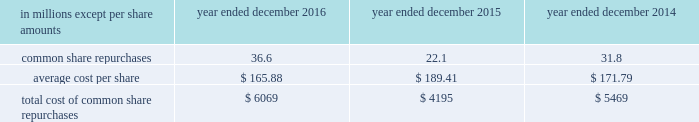The goldman sachs group , inc .
And subsidiaries notes to consolidated financial statements in connection with the firm 2019s prime brokerage and clearing businesses , the firm agrees to clear and settle on behalf of its clients the transactions entered into by them with other brokerage firms .
The firm 2019s obligations in respect of such transactions are secured by the assets in the client 2019s account as well as any proceeds received from the transactions cleared and settled by the firm on behalf of the client .
In connection with joint venture investments , the firm may issue loan guarantees under which it may be liable in the event of fraud , misappropriation , environmental liabilities and certain other matters involving the borrower .
The firm is unable to develop an estimate of the maximum payout under these guarantees and indemnifications .
However , management believes that it is unlikely the firm will have to make any material payments under these arrangements , and no material liabilities related to these guarantees and indemnifications have been recognized in the consolidated statements of financial condition as of december 2016 and december 2015 .
Other representations , warranties and indemnifications .
The firm provides representations and warranties to counterparties in connection with a variety of commercial transactions and occasionally indemnifies them against potential losses caused by the breach of those representations and warranties .
The firm may also provide indemnifications protecting against changes in or adverse application of certain u.s .
Tax laws in connection with ordinary-course transactions such as securities issuances , borrowings or derivatives .
In addition , the firm may provide indemnifications to some counterparties to protect them in the event additional taxes are owed or payments are withheld , due either to a change in or an adverse application of certain non-u.s .
Tax laws .
These indemnifications generally are standard contractual terms and are entered into in the ordinary course of business .
Generally , there are no stated or notional amounts included in these indemnifications , and the contingencies triggering the obligation to indemnify are not expected to occur .
The firm is unable to develop an estimate of the maximum payout under these guarantees and indemnifications .
However , management believes that it is unlikely the firm will have to make any material payments under these arrangements , and no material liabilities related to these arrangements have been recognized in the consolidated statements of financial condition as of december 2016 and december 2015 .
Guarantees of subsidiaries .
Group inc .
Fully and unconditionally guarantees the securities issued by gs finance corp. , a wholly-owned finance subsidiary of the group inc .
Has guaranteed the payment obligations of goldman , sachs & co .
( gs&co. ) and gs bank usa , subject to certain exceptions .
In addition , group inc .
Guarantees many of the obligations of its other consolidated subsidiaries on a transaction-by- transaction basis , as negotiated with counterparties .
Group inc .
Is unable to develop an estimate of the maximum payout under its subsidiary guarantees ; however , because these guaranteed obligations are also obligations of consolidated subsidiaries , group inc . 2019s liabilities as guarantor are not separately disclosed .
Note 19 .
Shareholders 2019 equity common equity dividends declared per common share were $ 2.60 in 2016 , $ 2.55 in 2015 and $ 2.25 in 2014 .
On january 17 , 2017 , group inc .
Declared a dividend of $ 0.65 per common share to be paid on march 30 , 2017 to common shareholders of record on march 2 , 2017 .
The firm 2019s share repurchase program is intended to help maintain the appropriate level of common equity .
The share repurchase program is effected primarily through regular open-market purchases ( which may include repurchase plans designed to comply with rule 10b5-1 ) , the amounts and timing of which are determined primarily by the firm 2019s current and projected capital position , but which may also be influenced by general market conditions and the prevailing price and trading volumes of the firm 2019s common stock .
Prior to repurchasing common stock , the firm must receive confirmation that the federal reserve board does not object to such capital actions .
The table below presents the amount of common stock repurchased by the firm under the share repurchase program. .
172 goldman sachs 2016 form 10-k .
What was total shareholders 2019 equity common equity dividends declared per common share in 2016 , 2015 and 2014? 
Computations: ((2.60 + 2.55) + 2.25)
Answer: 7.4. 